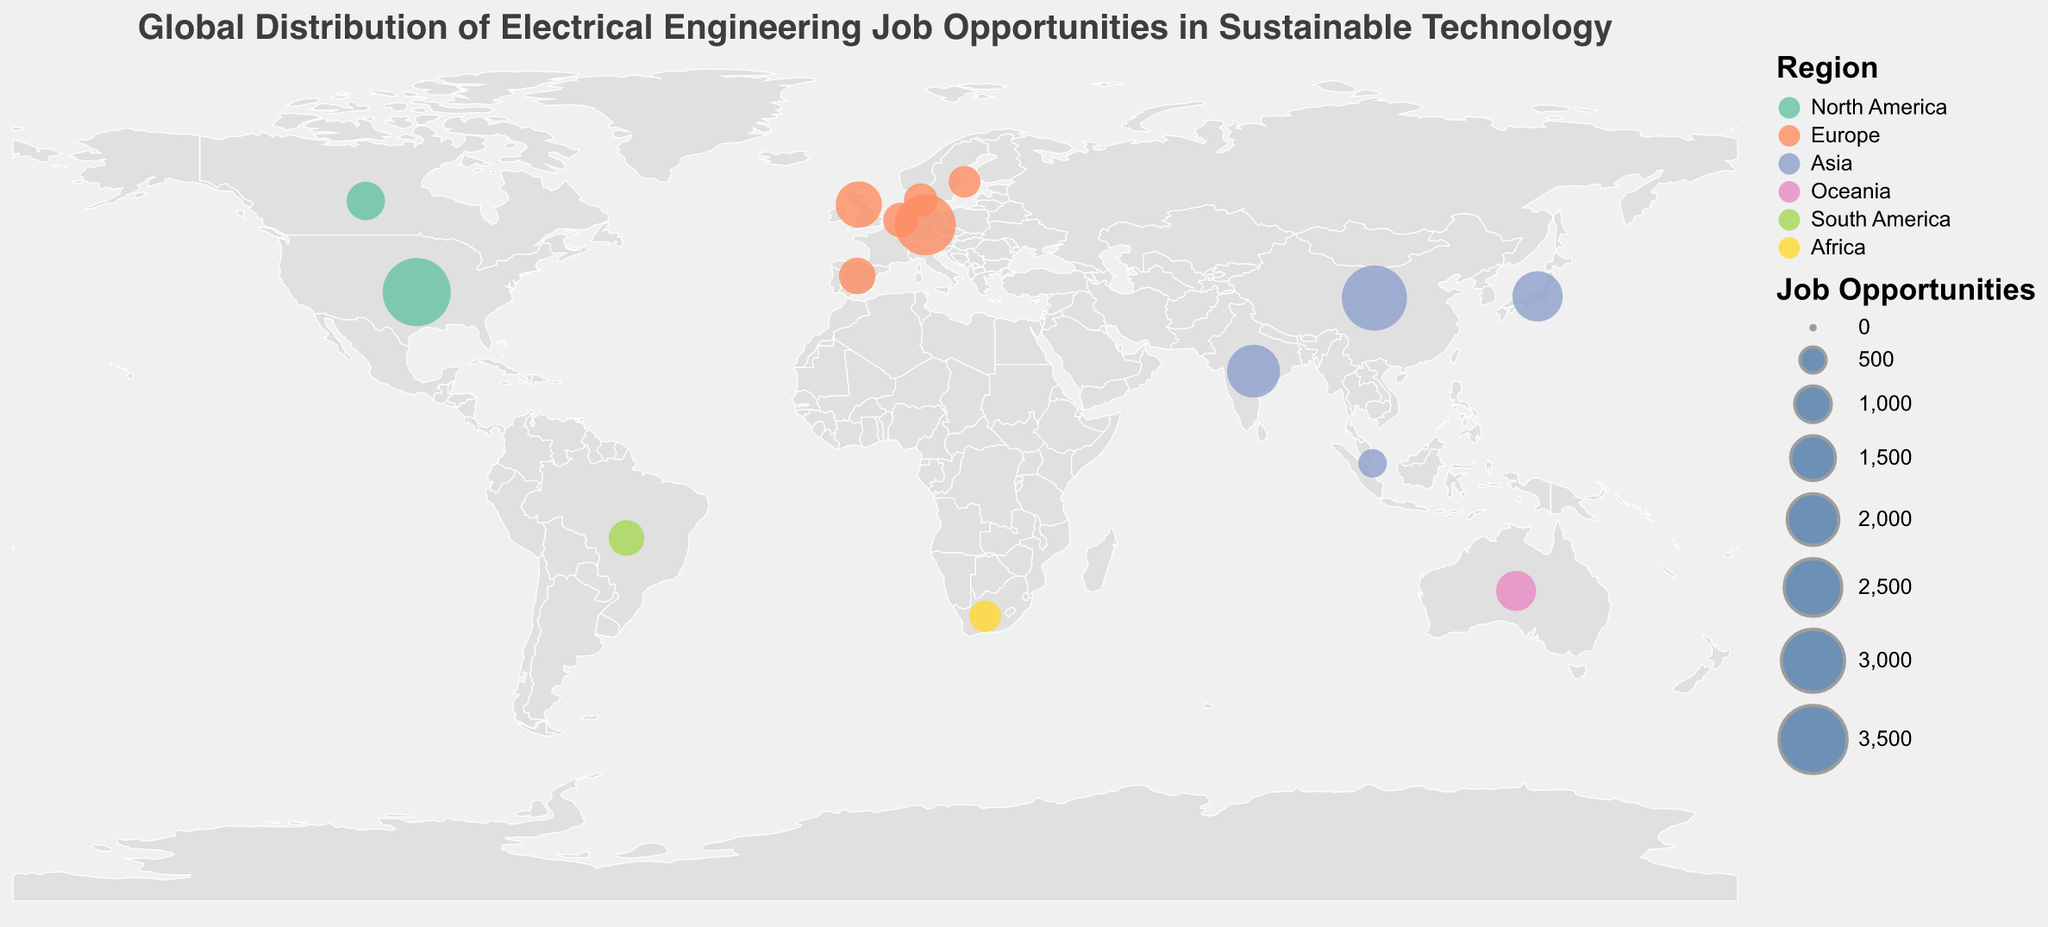What is the title of the plot? The title of the plot can be found at the top of the figure. It is displayed in a larger font size and typically summarizes the content of the plot in a few words.
Answer: Global Distribution of Electrical Engineering Job Opportunities in Sustainable Technology Which country has the highest number of job opportunities in sustainable technology sectors? The job opportunities are indicated by the size of the circles. The largest circle corresponds to the United States.
Answer: United States How many job opportunities are there in China? To find the number of job opportunities in China, look at the tooltip or the size of the circle located in Asia around China's longitude and latitude. The tooltip specifies this information clearly when hovering over the circle.
Answer: 3200 Which region has the most countries listed in the plot? To determine this, count the number of countries listed within each region. The regions include North America, Europe, Asia, Oceania, South America, and Africa. Europe has Germany, United Kingdom, Denmark, Spain, Netherlands, and Sweden, which is the most among the regions.
Answer: Europe What sustainability focus is associated with the electrical engineering job opportunities in Australia? Each country’s sustainability focus is shown in the tooltip or can be deduced from the label next to the respective country. For Australia, it is 'Off-Grid Power Systems'.
Answer: Off-Grid Power Systems Compare the number of job opportunities between Germany and Japan. Which country has more? Look at the circles for Germany and Japan. Germany's circle is larger and its tooltip shows 2800 job opportunities, while Japan’s circle shows 1900.
Answer: Germany Which sustainability technology has the least job opportunities according to the plot, and in which country? By examining the circles and tooltips, you can identify that Singapore has the least number of jobs, with 600 opportunities in 'Energy Management Systems'.
Answer: Energy Management Systems in Singapore What is the total number of job opportunities in Asia? Sum the job opportunities of all countries listed under the Asia region: China (3200), India (2100), Japan (1900), and Singapore (600). The total is 3200 + 2100 + 1900 + 600.
Answer: 7800 How does the job opportunity count in Brazil compare to that in South Africa? By examining the circles for these countries and their tooltip data, Brazil has 950 job opportunities, whereas South Africa has 750. Therefore, Brazil has more job opportunities than South Africa.
Answer: Brazil What region does the color represented by "#fc8d62" on the plot correspond to? By looking at the legend associated with the plot, the color "#fc8d62" corresponds to the region of Europe.
Answer: Europe 